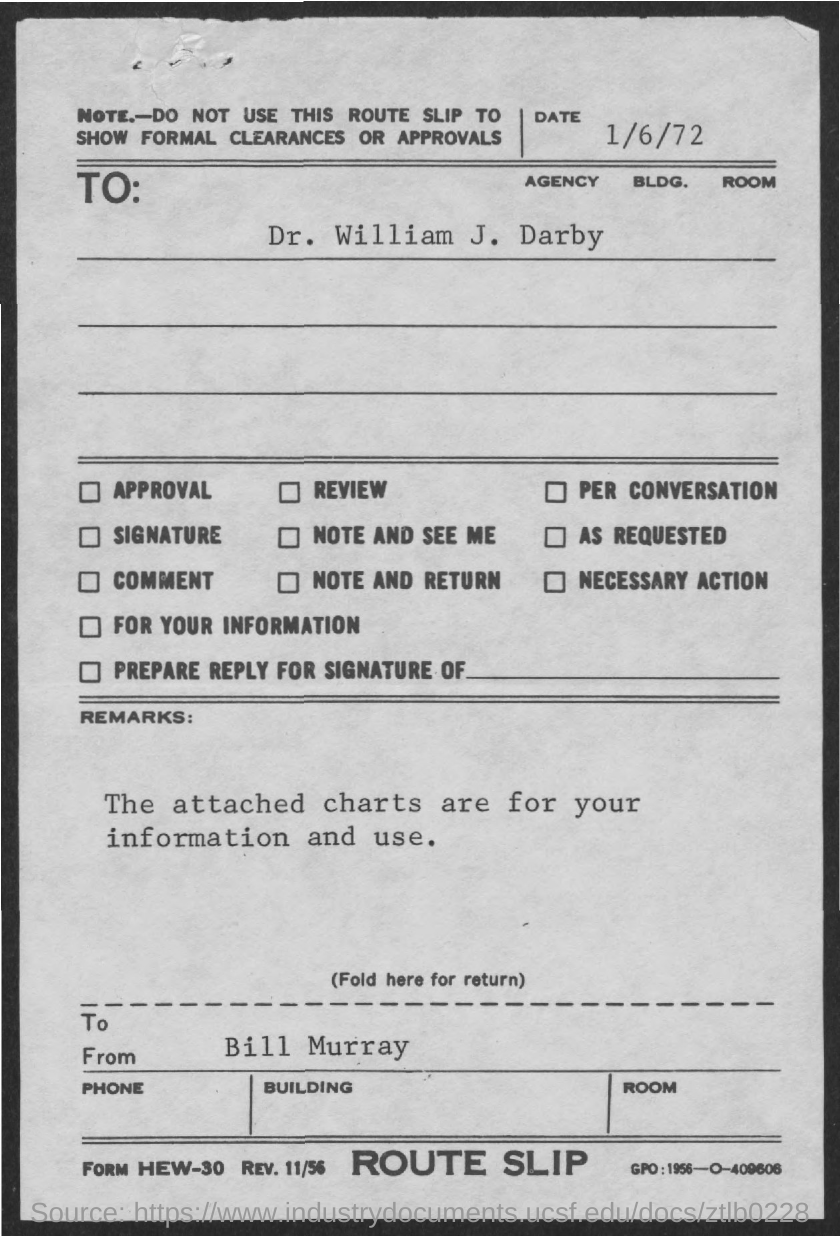What is the "note" given in this slip?
Ensure brevity in your answer.  Do not use this route slip to show formal clearances or approvals. What is the date mentioned?
Ensure brevity in your answer.  1/6/72. What is the remarks?
Offer a terse response. The attached charts are for your information and use. What type of slip is it?
Offer a very short reply. Route slip. 